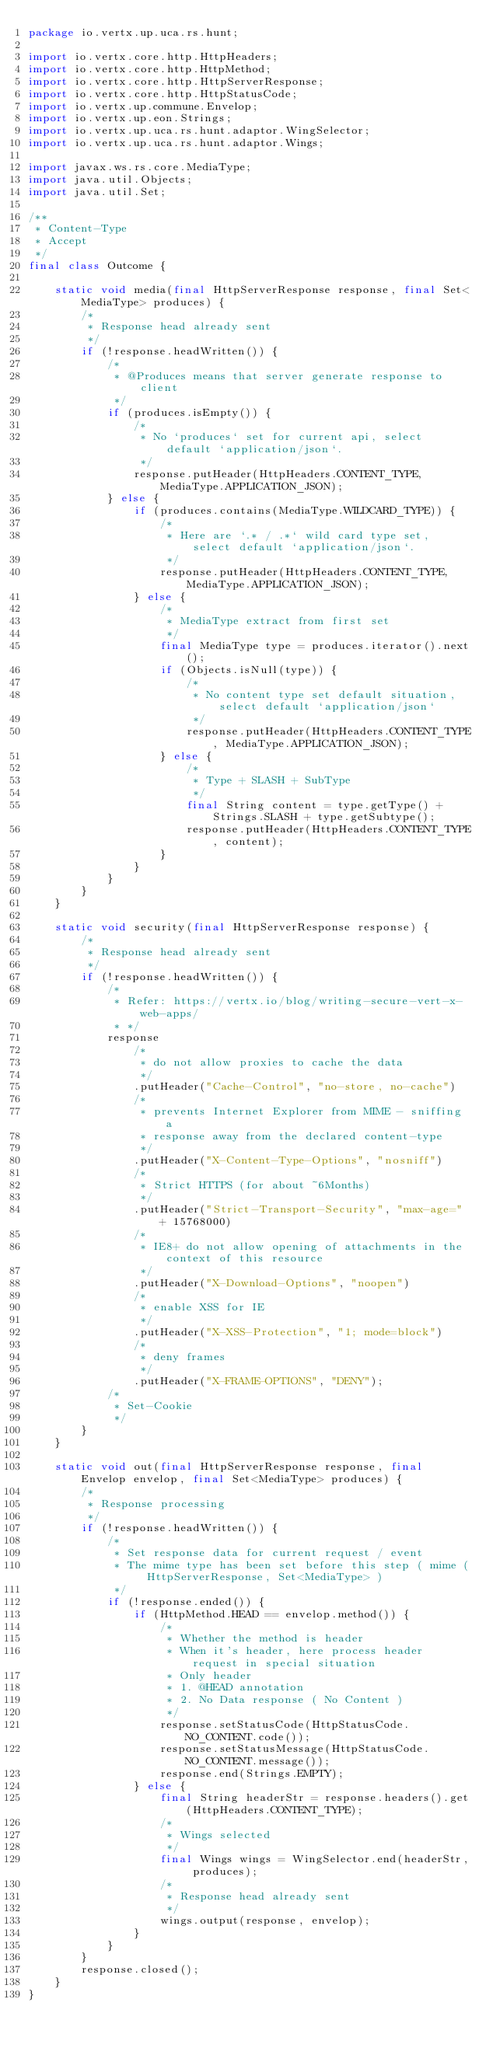Convert code to text. <code><loc_0><loc_0><loc_500><loc_500><_Java_>package io.vertx.up.uca.rs.hunt;

import io.vertx.core.http.HttpHeaders;
import io.vertx.core.http.HttpMethod;
import io.vertx.core.http.HttpServerResponse;
import io.vertx.core.http.HttpStatusCode;
import io.vertx.up.commune.Envelop;
import io.vertx.up.eon.Strings;
import io.vertx.up.uca.rs.hunt.adaptor.WingSelector;
import io.vertx.up.uca.rs.hunt.adaptor.Wings;

import javax.ws.rs.core.MediaType;
import java.util.Objects;
import java.util.Set;

/**
 * Content-Type
 * Accept
 */
final class Outcome {

    static void media(final HttpServerResponse response, final Set<MediaType> produces) {
        /*
         * Response head already sent
         */
        if (!response.headWritten()) {
            /*
             * @Produces means that server generate response to client
             */
            if (produces.isEmpty()) {
                /*
                 * No `produces` set for current api, select default `application/json`.
                 */
                response.putHeader(HttpHeaders.CONTENT_TYPE, MediaType.APPLICATION_JSON);
            } else {
                if (produces.contains(MediaType.WILDCARD_TYPE)) {
                    /*
                     * Here are `.* / .*` wild card type set, select default `application/json`.
                     */
                    response.putHeader(HttpHeaders.CONTENT_TYPE, MediaType.APPLICATION_JSON);
                } else {
                    /*
                     * MediaType extract from first set
                     */
                    final MediaType type = produces.iterator().next();
                    if (Objects.isNull(type)) {
                        /*
                         * No content type set default situation, select default `application/json`
                         */
                        response.putHeader(HttpHeaders.CONTENT_TYPE, MediaType.APPLICATION_JSON);
                    } else {
                        /*
                         * Type + SLASH + SubType
                         */
                        final String content = type.getType() + Strings.SLASH + type.getSubtype();
                        response.putHeader(HttpHeaders.CONTENT_TYPE, content);
                    }
                }
            }
        }
    }

    static void security(final HttpServerResponse response) {
        /*
         * Response head already sent
         */
        if (!response.headWritten()) {
            /*
             * Refer: https://vertx.io/blog/writing-secure-vert-x-web-apps/
             * */
            response
                /*
                 * do not allow proxies to cache the data
                 */
                .putHeader("Cache-Control", "no-store, no-cache")
                /*
                 * prevents Internet Explorer from MIME - sniffing a
                 * response away from the declared content-type
                 */
                .putHeader("X-Content-Type-Options", "nosniff")
                /*
                 * Strict HTTPS (for about ~6Months)
                 */
                .putHeader("Strict-Transport-Security", "max-age=" + 15768000)
                /*
                 * IE8+ do not allow opening of attachments in the context of this resource
                 */
                .putHeader("X-Download-Options", "noopen")
                /*
                 * enable XSS for IE
                 */
                .putHeader("X-XSS-Protection", "1; mode=block")
                /*
                 * deny frames
                 */
                .putHeader("X-FRAME-OPTIONS", "DENY");
            /*
             * Set-Cookie
             */
        }
    }

    static void out(final HttpServerResponse response, final Envelop envelop, final Set<MediaType> produces) {
        /*
         * Response processing
         */
        if (!response.headWritten()) {
            /*
             * Set response data for current request / event
             * The mime type has been set before this step ( mime ( HttpServerResponse, Set<MediaType> )
             */
            if (!response.ended()) {
                if (HttpMethod.HEAD == envelop.method()) {
                    /*
                     * Whether the method is header
                     * When it's header, here process header request in special situation
                     * Only header
                     * 1. @HEAD annotation
                     * 2. No Data response ( No Content )
                     */
                    response.setStatusCode(HttpStatusCode.NO_CONTENT.code());
                    response.setStatusMessage(HttpStatusCode.NO_CONTENT.message());
                    response.end(Strings.EMPTY);
                } else {
                    final String headerStr = response.headers().get(HttpHeaders.CONTENT_TYPE);
                    /*
                     * Wings selected
                     */
                    final Wings wings = WingSelector.end(headerStr, produces);
                    /*
                     * Response head already sent
                     */
                    wings.output(response, envelop);
                }
            }
        }
        response.closed();
    }
}
</code> 